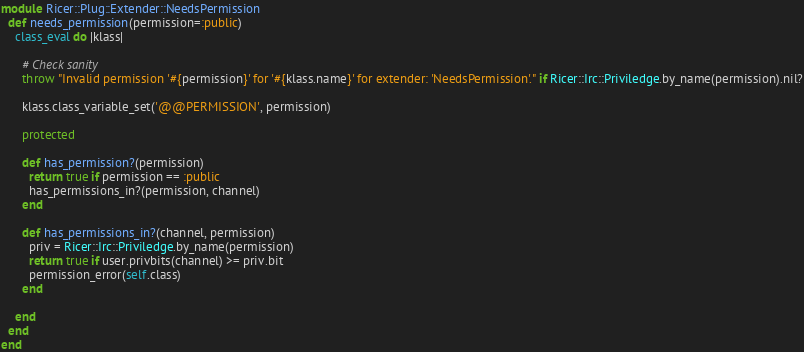<code> <loc_0><loc_0><loc_500><loc_500><_Ruby_>module Ricer::Plug::Extender::NeedsPermission
  def needs_permission(permission=:public)
    class_eval do |klass|
      
      # Check sanity
      throw "Invalid permission '#{permission}' for '#{klass.name}' for extender: 'NeedsPermission'." if Ricer::Irc::Priviledge.by_name(permission).nil?
      
      klass.class_variable_set('@@PERMISSION', permission)
      
      protected
      
      def has_permission?(permission)
        return true if permission == :public
        has_permissions_in?(permission, channel)
      end
      
      def has_permissions_in?(channel, permission)
        priv = Ricer::Irc::Priviledge.by_name(permission)
        return true if user.privbits(channel) >= priv.bit
        permission_error(self.class)
      end
      
    end
  end
end
</code> 